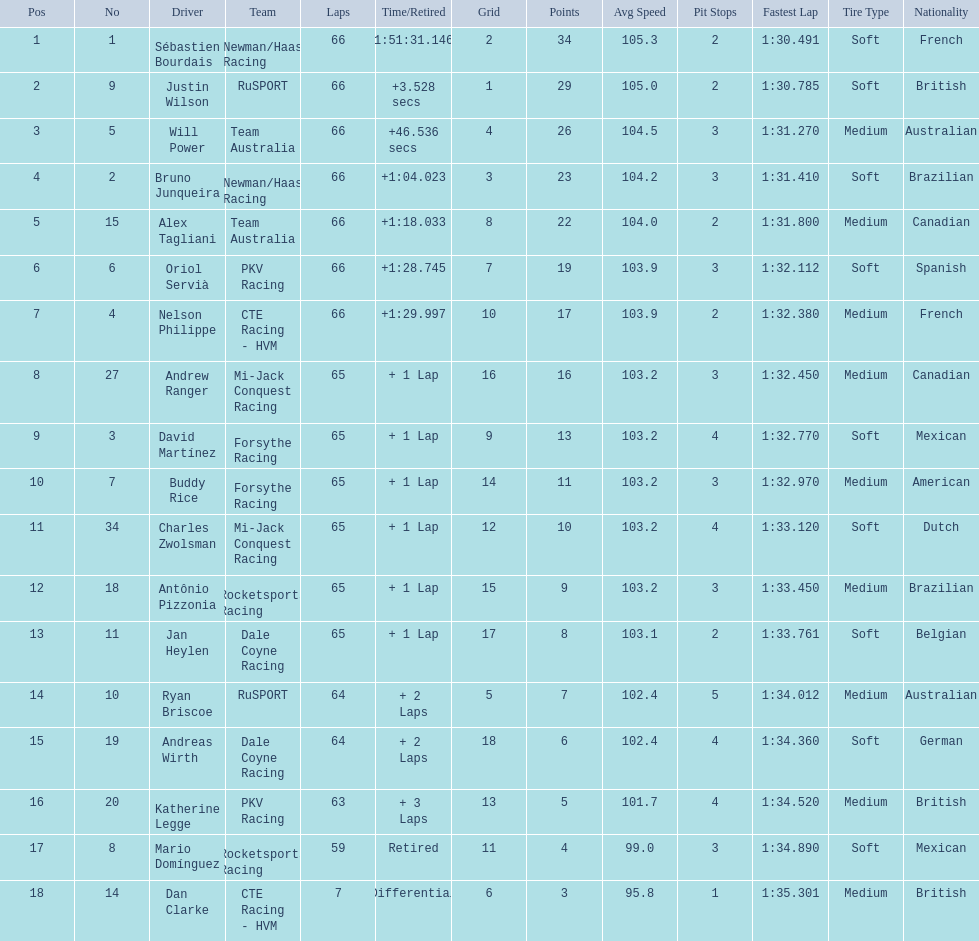Who are all of the 2006 gran premio telmex drivers? Sébastien Bourdais, Justin Wilson, Will Power, Bruno Junqueira, Alex Tagliani, Oriol Servià, Nelson Philippe, Andrew Ranger, David Martínez, Buddy Rice, Charles Zwolsman, Antônio Pizzonia, Jan Heylen, Ryan Briscoe, Andreas Wirth, Katherine Legge, Mario Domínguez, Dan Clarke. How many laps did they finish? 66, 66, 66, 66, 66, 66, 66, 65, 65, 65, 65, 65, 65, 64, 64, 63, 59, 7. What about just oriol servia and katherine legge? 66, 63. And which of those two drivers finished more laps? Oriol Servià. 